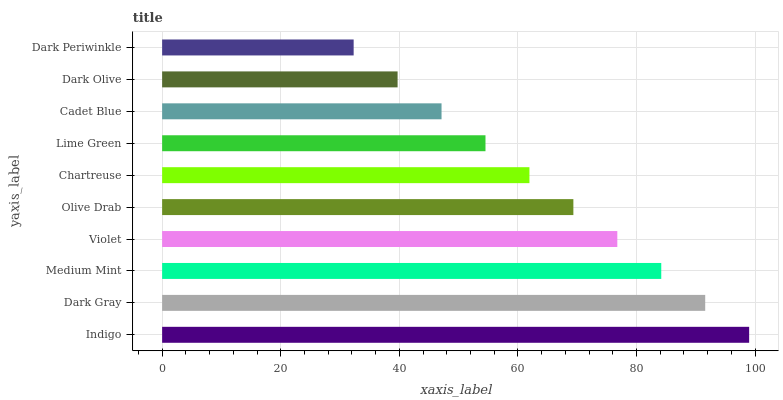Is Dark Periwinkle the minimum?
Answer yes or no. Yes. Is Indigo the maximum?
Answer yes or no. Yes. Is Dark Gray the minimum?
Answer yes or no. No. Is Dark Gray the maximum?
Answer yes or no. No. Is Indigo greater than Dark Gray?
Answer yes or no. Yes. Is Dark Gray less than Indigo?
Answer yes or no. Yes. Is Dark Gray greater than Indigo?
Answer yes or no. No. Is Indigo less than Dark Gray?
Answer yes or no. No. Is Olive Drab the high median?
Answer yes or no. Yes. Is Chartreuse the low median?
Answer yes or no. Yes. Is Cadet Blue the high median?
Answer yes or no. No. Is Cadet Blue the low median?
Answer yes or no. No. 